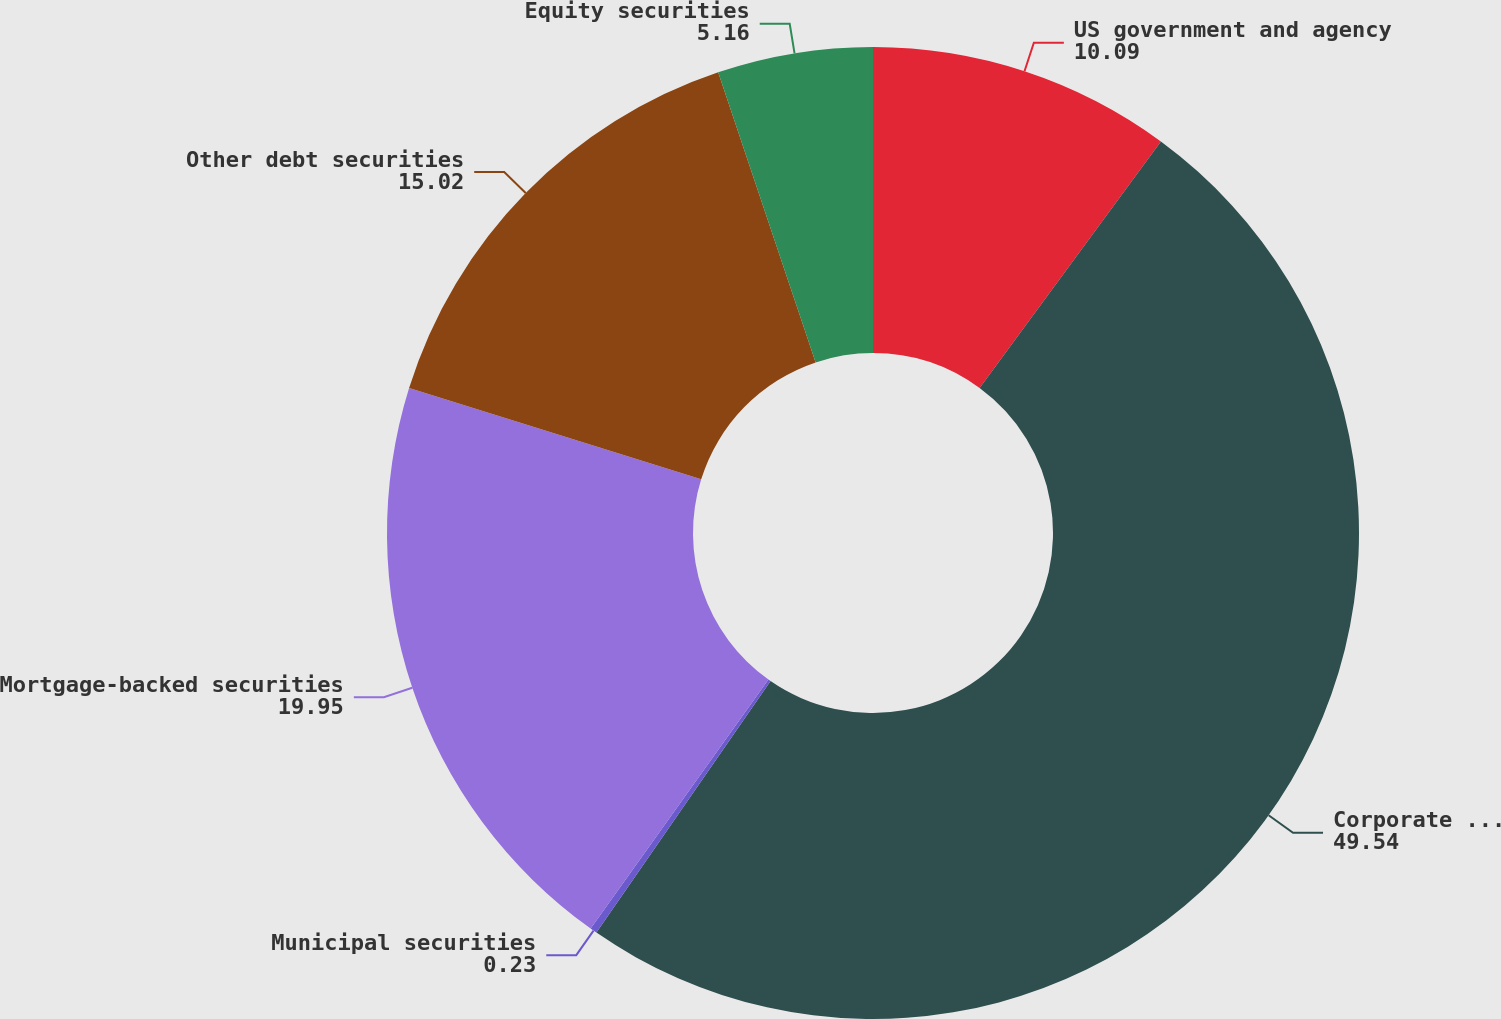<chart> <loc_0><loc_0><loc_500><loc_500><pie_chart><fcel>US government and agency<fcel>Corporate notes and bonds<fcel>Municipal securities<fcel>Mortgage-backed securities<fcel>Other debt securities<fcel>Equity securities<nl><fcel>10.09%<fcel>49.54%<fcel>0.23%<fcel>19.95%<fcel>15.02%<fcel>5.16%<nl></chart> 